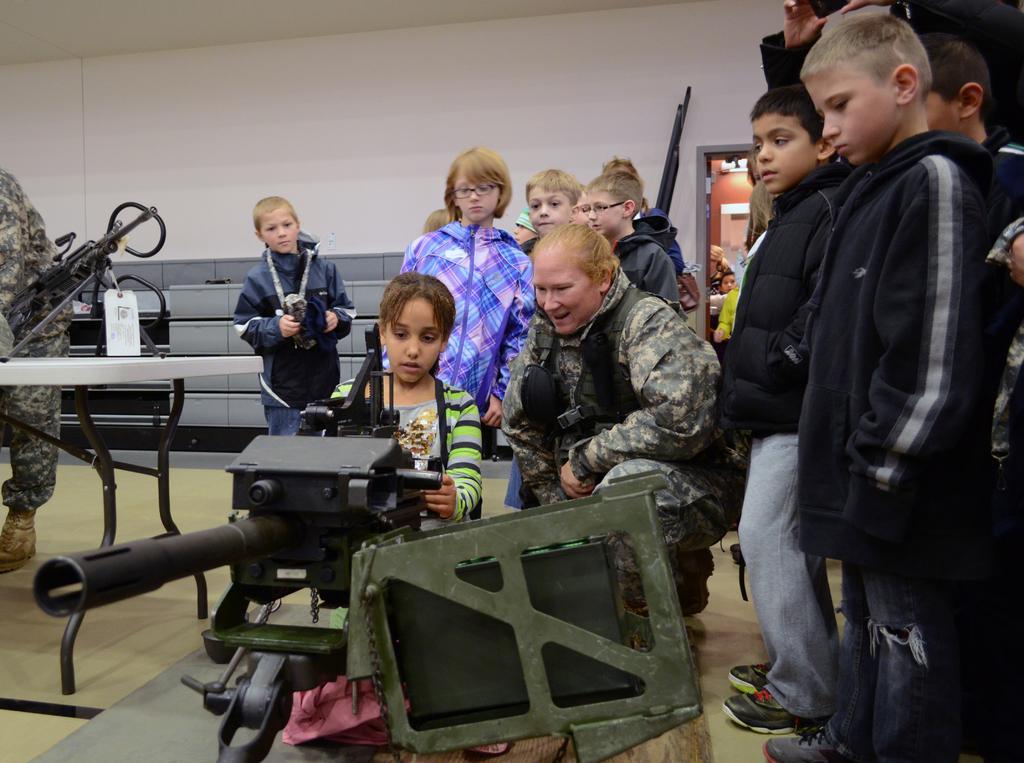Please provide a concise description of this image. In this image we can see there are a few people standing and looking into the object. On the left side of the image there is a table. On the table there is an object. In front of the table there is a person standing. In the background there is a wall. 